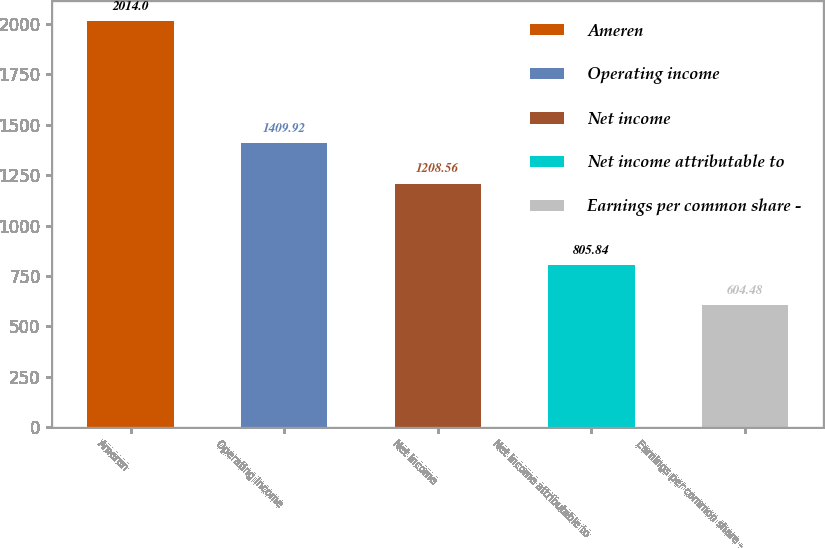Convert chart to OTSL. <chart><loc_0><loc_0><loc_500><loc_500><bar_chart><fcel>Ameren<fcel>Operating income<fcel>Net income<fcel>Net income attributable to<fcel>Earnings per common share -<nl><fcel>2014<fcel>1409.92<fcel>1208.56<fcel>805.84<fcel>604.48<nl></chart> 